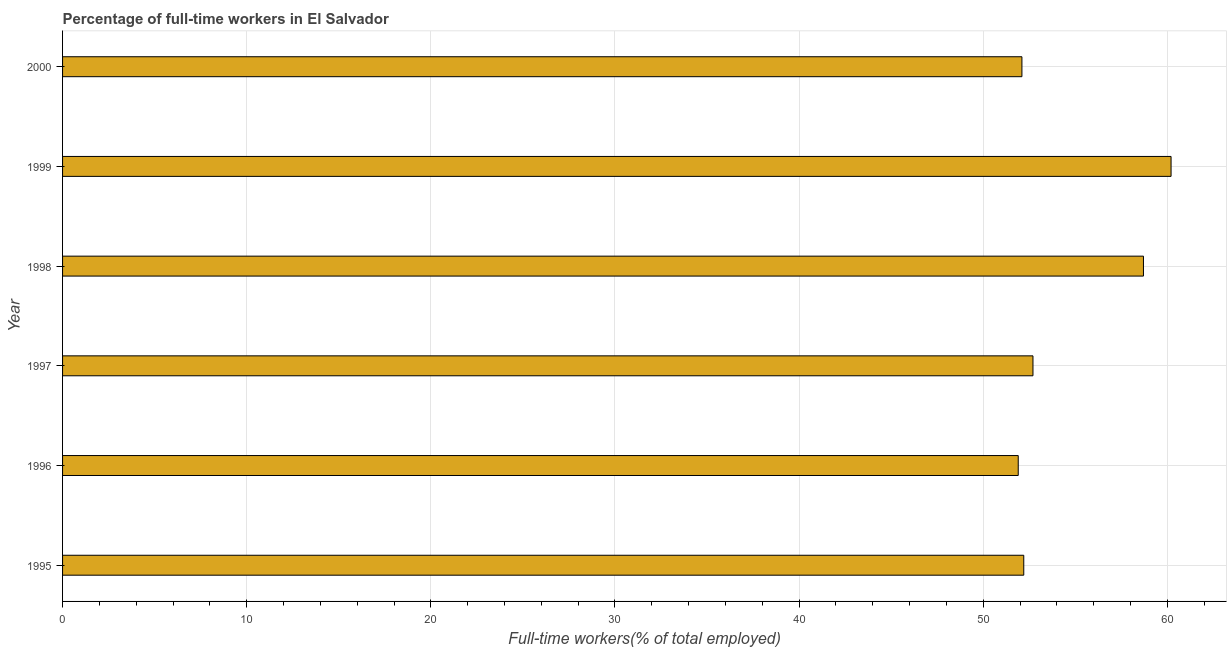Does the graph contain any zero values?
Ensure brevity in your answer.  No. Does the graph contain grids?
Provide a succinct answer. Yes. What is the title of the graph?
Your answer should be very brief. Percentage of full-time workers in El Salvador. What is the label or title of the X-axis?
Provide a short and direct response. Full-time workers(% of total employed). What is the label or title of the Y-axis?
Keep it short and to the point. Year. What is the percentage of full-time workers in 1995?
Ensure brevity in your answer.  52.2. Across all years, what is the maximum percentage of full-time workers?
Give a very brief answer. 60.2. Across all years, what is the minimum percentage of full-time workers?
Offer a terse response. 51.9. What is the sum of the percentage of full-time workers?
Keep it short and to the point. 327.8. What is the difference between the percentage of full-time workers in 1997 and 2000?
Provide a succinct answer. 0.6. What is the average percentage of full-time workers per year?
Keep it short and to the point. 54.63. What is the median percentage of full-time workers?
Your response must be concise. 52.45. In how many years, is the percentage of full-time workers greater than 34 %?
Keep it short and to the point. 6. What is the ratio of the percentage of full-time workers in 1998 to that in 1999?
Ensure brevity in your answer.  0.97. Is the percentage of full-time workers in 1996 less than that in 2000?
Your answer should be very brief. Yes. Is the difference between the percentage of full-time workers in 1996 and 1997 greater than the difference between any two years?
Provide a short and direct response. No. What is the difference between the highest and the second highest percentage of full-time workers?
Provide a succinct answer. 1.5. Is the sum of the percentage of full-time workers in 1995 and 1998 greater than the maximum percentage of full-time workers across all years?
Keep it short and to the point. Yes. What is the difference between the highest and the lowest percentage of full-time workers?
Your answer should be very brief. 8.3. In how many years, is the percentage of full-time workers greater than the average percentage of full-time workers taken over all years?
Ensure brevity in your answer.  2. How many bars are there?
Ensure brevity in your answer.  6. Are all the bars in the graph horizontal?
Make the answer very short. Yes. How many years are there in the graph?
Provide a short and direct response. 6. What is the difference between two consecutive major ticks on the X-axis?
Your answer should be compact. 10. What is the Full-time workers(% of total employed) of 1995?
Ensure brevity in your answer.  52.2. What is the Full-time workers(% of total employed) in 1996?
Provide a succinct answer. 51.9. What is the Full-time workers(% of total employed) of 1997?
Keep it short and to the point. 52.7. What is the Full-time workers(% of total employed) of 1998?
Your answer should be very brief. 58.7. What is the Full-time workers(% of total employed) of 1999?
Offer a terse response. 60.2. What is the Full-time workers(% of total employed) in 2000?
Keep it short and to the point. 52.1. What is the difference between the Full-time workers(% of total employed) in 1995 and 1996?
Provide a succinct answer. 0.3. What is the difference between the Full-time workers(% of total employed) in 1995 and 1999?
Ensure brevity in your answer.  -8. What is the difference between the Full-time workers(% of total employed) in 1996 and 1997?
Give a very brief answer. -0.8. What is the difference between the Full-time workers(% of total employed) in 1996 and 1998?
Make the answer very short. -6.8. What is the difference between the Full-time workers(% of total employed) in 1997 and 1998?
Your answer should be compact. -6. What is the difference between the Full-time workers(% of total employed) in 1997 and 2000?
Provide a short and direct response. 0.6. What is the difference between the Full-time workers(% of total employed) in 1998 and 2000?
Offer a very short reply. 6.6. What is the ratio of the Full-time workers(% of total employed) in 1995 to that in 1997?
Make the answer very short. 0.99. What is the ratio of the Full-time workers(% of total employed) in 1995 to that in 1998?
Offer a very short reply. 0.89. What is the ratio of the Full-time workers(% of total employed) in 1995 to that in 1999?
Offer a very short reply. 0.87. What is the ratio of the Full-time workers(% of total employed) in 1995 to that in 2000?
Your response must be concise. 1. What is the ratio of the Full-time workers(% of total employed) in 1996 to that in 1997?
Offer a terse response. 0.98. What is the ratio of the Full-time workers(% of total employed) in 1996 to that in 1998?
Ensure brevity in your answer.  0.88. What is the ratio of the Full-time workers(% of total employed) in 1996 to that in 1999?
Give a very brief answer. 0.86. What is the ratio of the Full-time workers(% of total employed) in 1997 to that in 1998?
Offer a very short reply. 0.9. What is the ratio of the Full-time workers(% of total employed) in 1997 to that in 2000?
Make the answer very short. 1.01. What is the ratio of the Full-time workers(% of total employed) in 1998 to that in 1999?
Ensure brevity in your answer.  0.97. What is the ratio of the Full-time workers(% of total employed) in 1998 to that in 2000?
Keep it short and to the point. 1.13. What is the ratio of the Full-time workers(% of total employed) in 1999 to that in 2000?
Your answer should be compact. 1.16. 